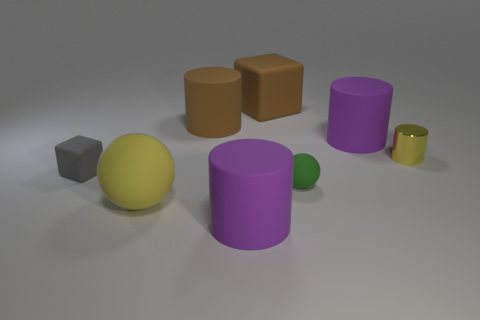Add 1 big brown rubber cylinders. How many objects exist? 9 Subtract all tiny yellow cylinders. How many cylinders are left? 3 Subtract all cyan spheres. How many purple cylinders are left? 2 Subtract 1 cylinders. How many cylinders are left? 3 Subtract all red balls. Subtract all purple cubes. How many balls are left? 2 Subtract all tiny green rubber things. Subtract all big brown cubes. How many objects are left? 6 Add 6 small green matte things. How many small green matte things are left? 7 Add 8 small yellow metallic things. How many small yellow metallic things exist? 9 Subtract all gray cubes. How many cubes are left? 1 Subtract 0 green cylinders. How many objects are left? 8 